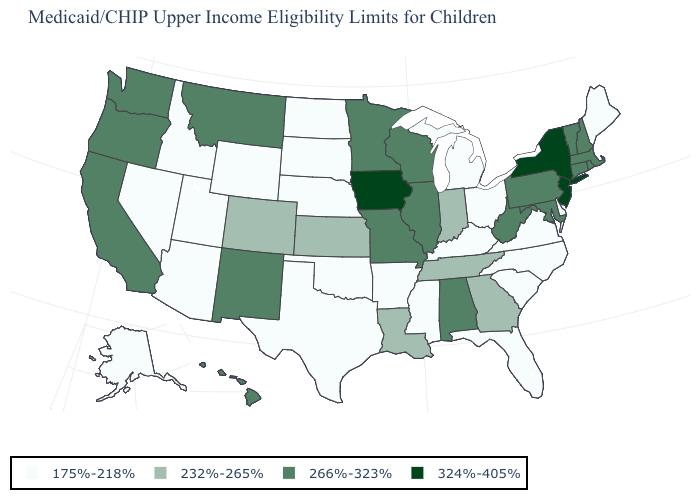Does the first symbol in the legend represent the smallest category?
Be succinct. Yes. Among the states that border Ohio , which have the lowest value?
Concise answer only. Kentucky, Michigan. What is the value of South Carolina?
Give a very brief answer. 175%-218%. What is the value of Hawaii?
Give a very brief answer. 266%-323%. What is the value of Minnesota?
Short answer required. 266%-323%. Name the states that have a value in the range 232%-265%?
Write a very short answer. Colorado, Georgia, Indiana, Kansas, Louisiana, Tennessee. Among the states that border Maryland , which have the lowest value?
Concise answer only. Delaware, Virginia. Name the states that have a value in the range 232%-265%?
Be succinct. Colorado, Georgia, Indiana, Kansas, Louisiana, Tennessee. What is the value of West Virginia?
Short answer required. 266%-323%. What is the value of West Virginia?
Write a very short answer. 266%-323%. Which states have the lowest value in the USA?
Quick response, please. Alaska, Arizona, Arkansas, Delaware, Florida, Idaho, Kentucky, Maine, Michigan, Mississippi, Nebraska, Nevada, North Carolina, North Dakota, Ohio, Oklahoma, South Carolina, South Dakota, Texas, Utah, Virginia, Wyoming. What is the value of Illinois?
Keep it brief. 266%-323%. Which states hav the highest value in the Northeast?
Concise answer only. New Jersey, New York. Which states hav the highest value in the West?
Answer briefly. California, Hawaii, Montana, New Mexico, Oregon, Washington. Among the states that border Kentucky , does West Virginia have the highest value?
Write a very short answer. Yes. 